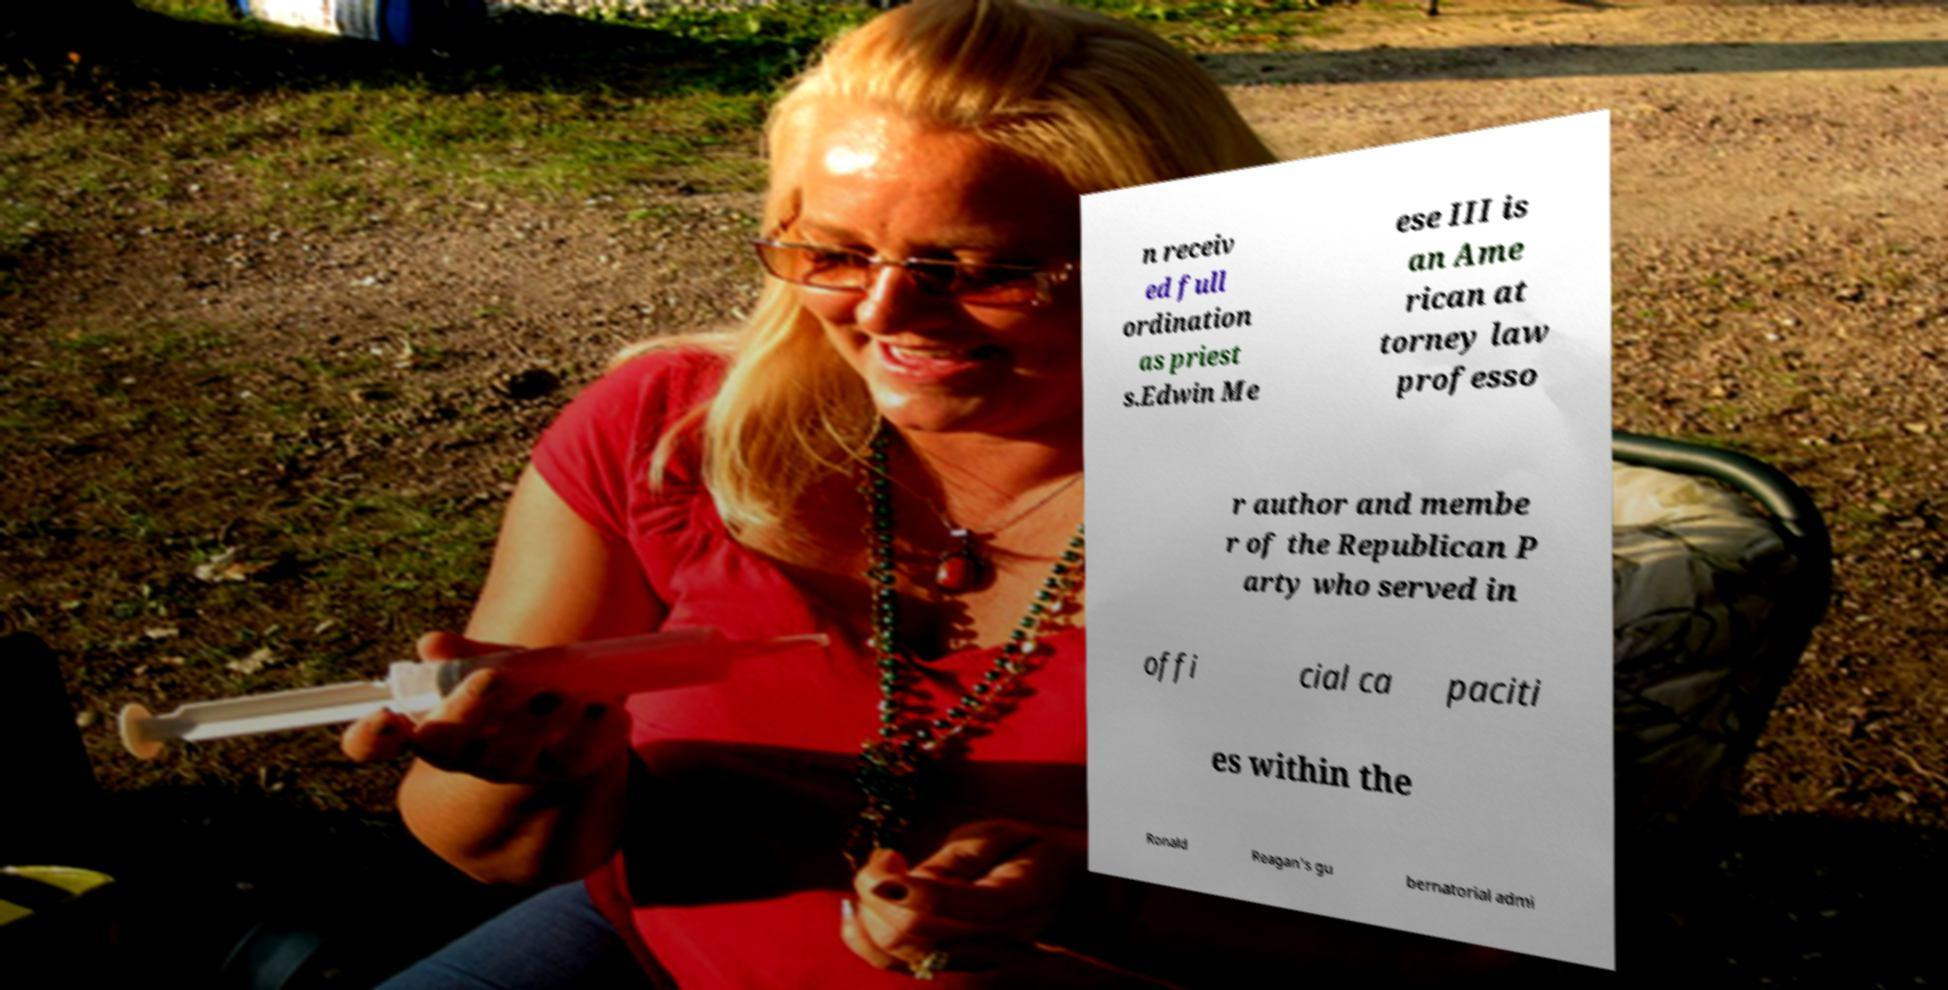Could you assist in decoding the text presented in this image and type it out clearly? n receiv ed full ordination as priest s.Edwin Me ese III is an Ame rican at torney law professo r author and membe r of the Republican P arty who served in offi cial ca paciti es within the Ronald Reagan's gu bernatorial admi 